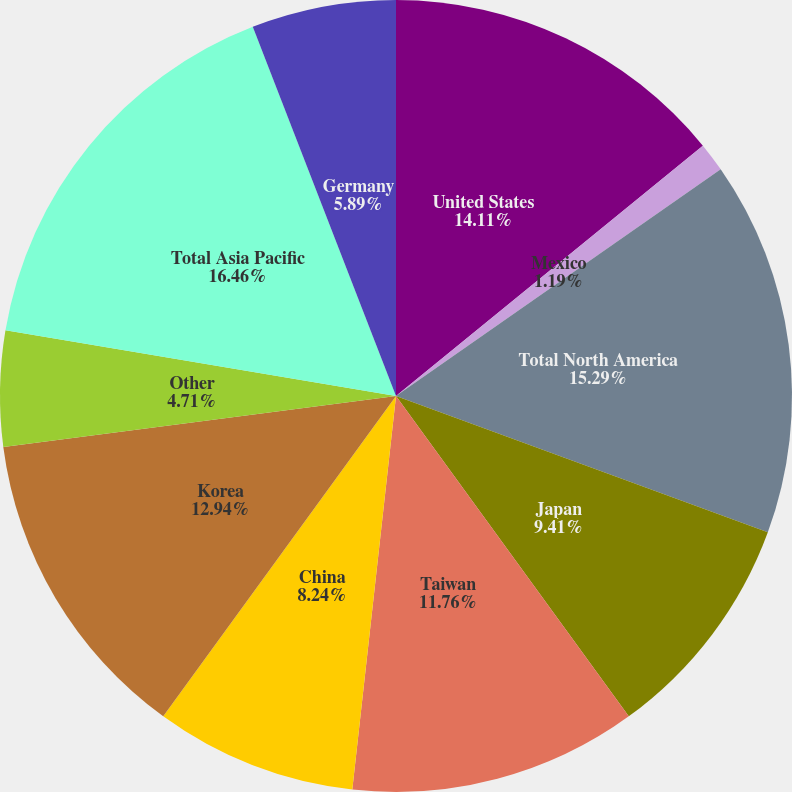<chart> <loc_0><loc_0><loc_500><loc_500><pie_chart><fcel>United States<fcel>Mexico<fcel>Total North America<fcel>Japan<fcel>Taiwan<fcel>China<fcel>Korea<fcel>Other<fcel>Total Asia Pacific<fcel>Germany<nl><fcel>14.11%<fcel>1.19%<fcel>15.29%<fcel>9.41%<fcel>11.76%<fcel>8.24%<fcel>12.94%<fcel>4.71%<fcel>16.46%<fcel>5.89%<nl></chart> 